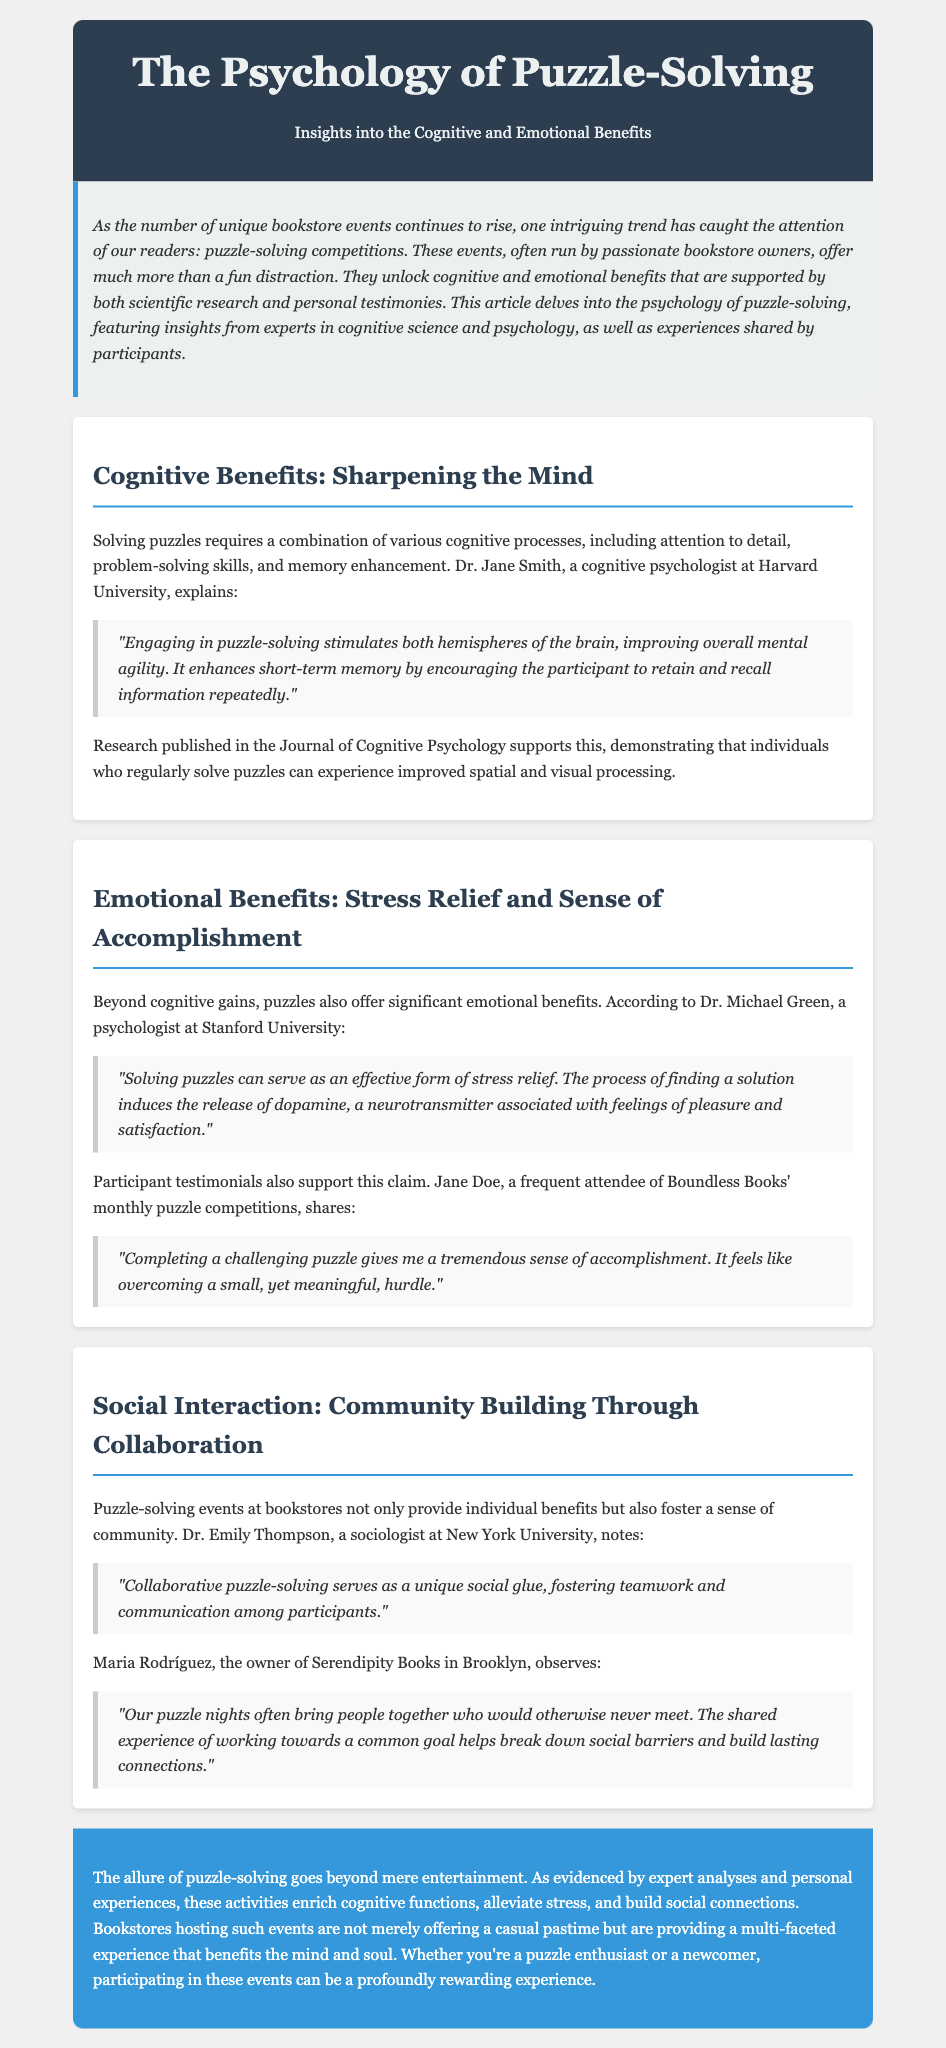What is the name of the article? The title of the article is indicated at the beginning of the document.
Answer: The Psychology of Puzzle-Solving Who is the cognitive psychologist mentioned in the document? The document cites Dr. Jane Smith, who is a cognitive psychologist at Harvard University.
Answer: Dr. Jane Smith What neurotransmitter is associated with feelings of pleasure mentioned in the document? The release of dopamine is noted as being associated with feelings of pleasure during puzzle-solving.
Answer: Dopamine Which bookstore hosts monthly puzzle competitions according to the document? Boundless Books is referred to as hosting monthly puzzle competitions in the document.
Answer: Boundless Books What is one cognitive process involved in solving puzzles according to Dr. Jane Smith? The document describes multiple cognitive processes, one being attention to detail involved in puzzle-solving.
Answer: Attention to detail How does Dr. Michael Green describe puzzle-solving's effect on stress? Dr. Michael Green describes puzzle-solving as an effective form of stress relief in the document.
Answer: Effective form of stress relief What community benefit does collaborative puzzle-solving provide? The document cites that collaborative puzzle-solving fosters teamwork and communication among participants.
Answer: Teamwork and communication Which owner observes the social benefits of puzzle nights? Maria Rodríguez, the owner of Serendipity Books, is mentioned in connection with the social benefits.
Answer: Maria Rodríguez 